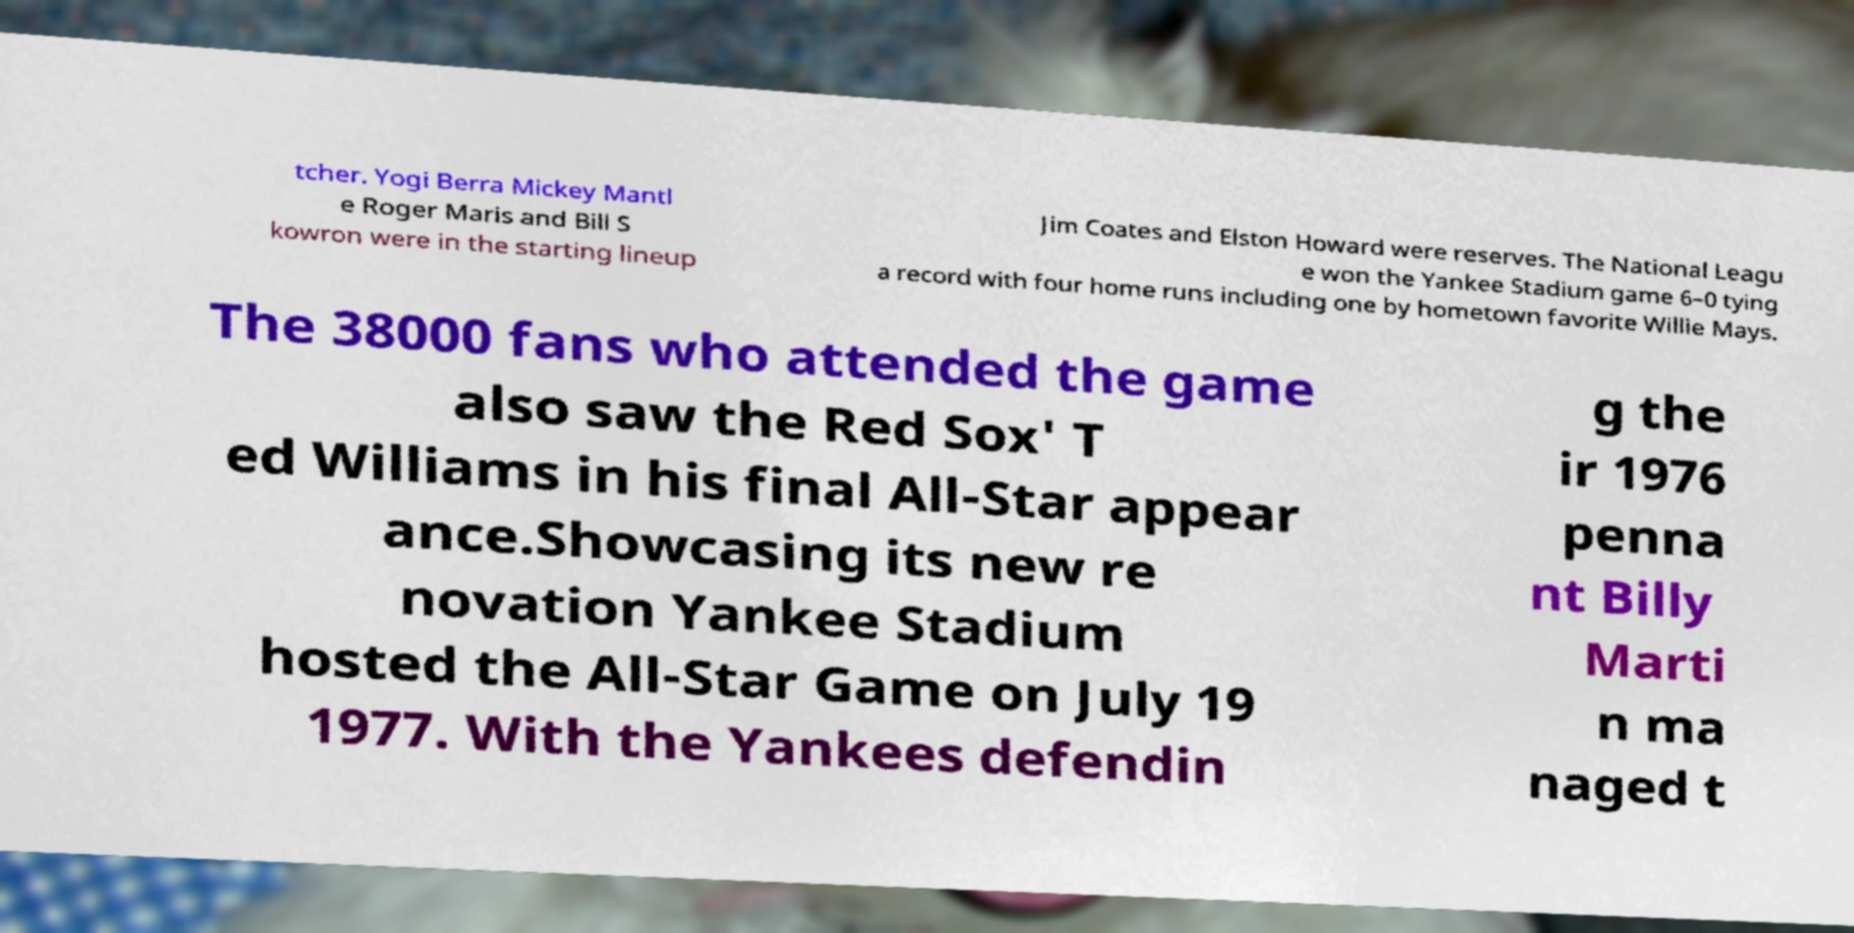Can you read and provide the text displayed in the image?This photo seems to have some interesting text. Can you extract and type it out for me? tcher. Yogi Berra Mickey Mantl e Roger Maris and Bill S kowron were in the starting lineup Jim Coates and Elston Howard were reserves. The National Leagu e won the Yankee Stadium game 6–0 tying a record with four home runs including one by hometown favorite Willie Mays. The 38000 fans who attended the game also saw the Red Sox' T ed Williams in his final All-Star appear ance.Showcasing its new re novation Yankee Stadium hosted the All-Star Game on July 19 1977. With the Yankees defendin g the ir 1976 penna nt Billy Marti n ma naged t 